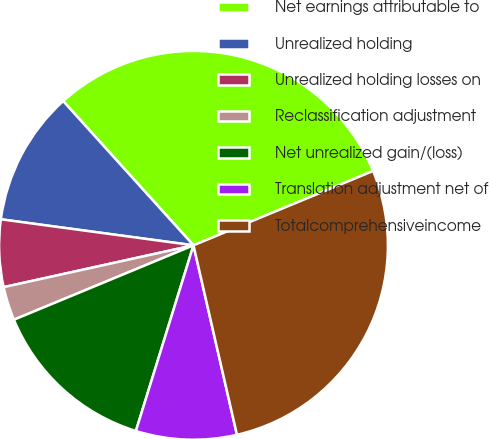Convert chart. <chart><loc_0><loc_0><loc_500><loc_500><pie_chart><fcel>Net earnings attributable to<fcel>Unrealized holding<fcel>Unrealized holding losses on<fcel>Reclassification adjustment<fcel>Net unrealized gain/(loss)<fcel>Translation adjustment net of<fcel>Totalcomprehensiveincome<nl><fcel>30.45%<fcel>11.17%<fcel>5.59%<fcel>2.8%<fcel>13.96%<fcel>8.38%<fcel>27.66%<nl></chart> 